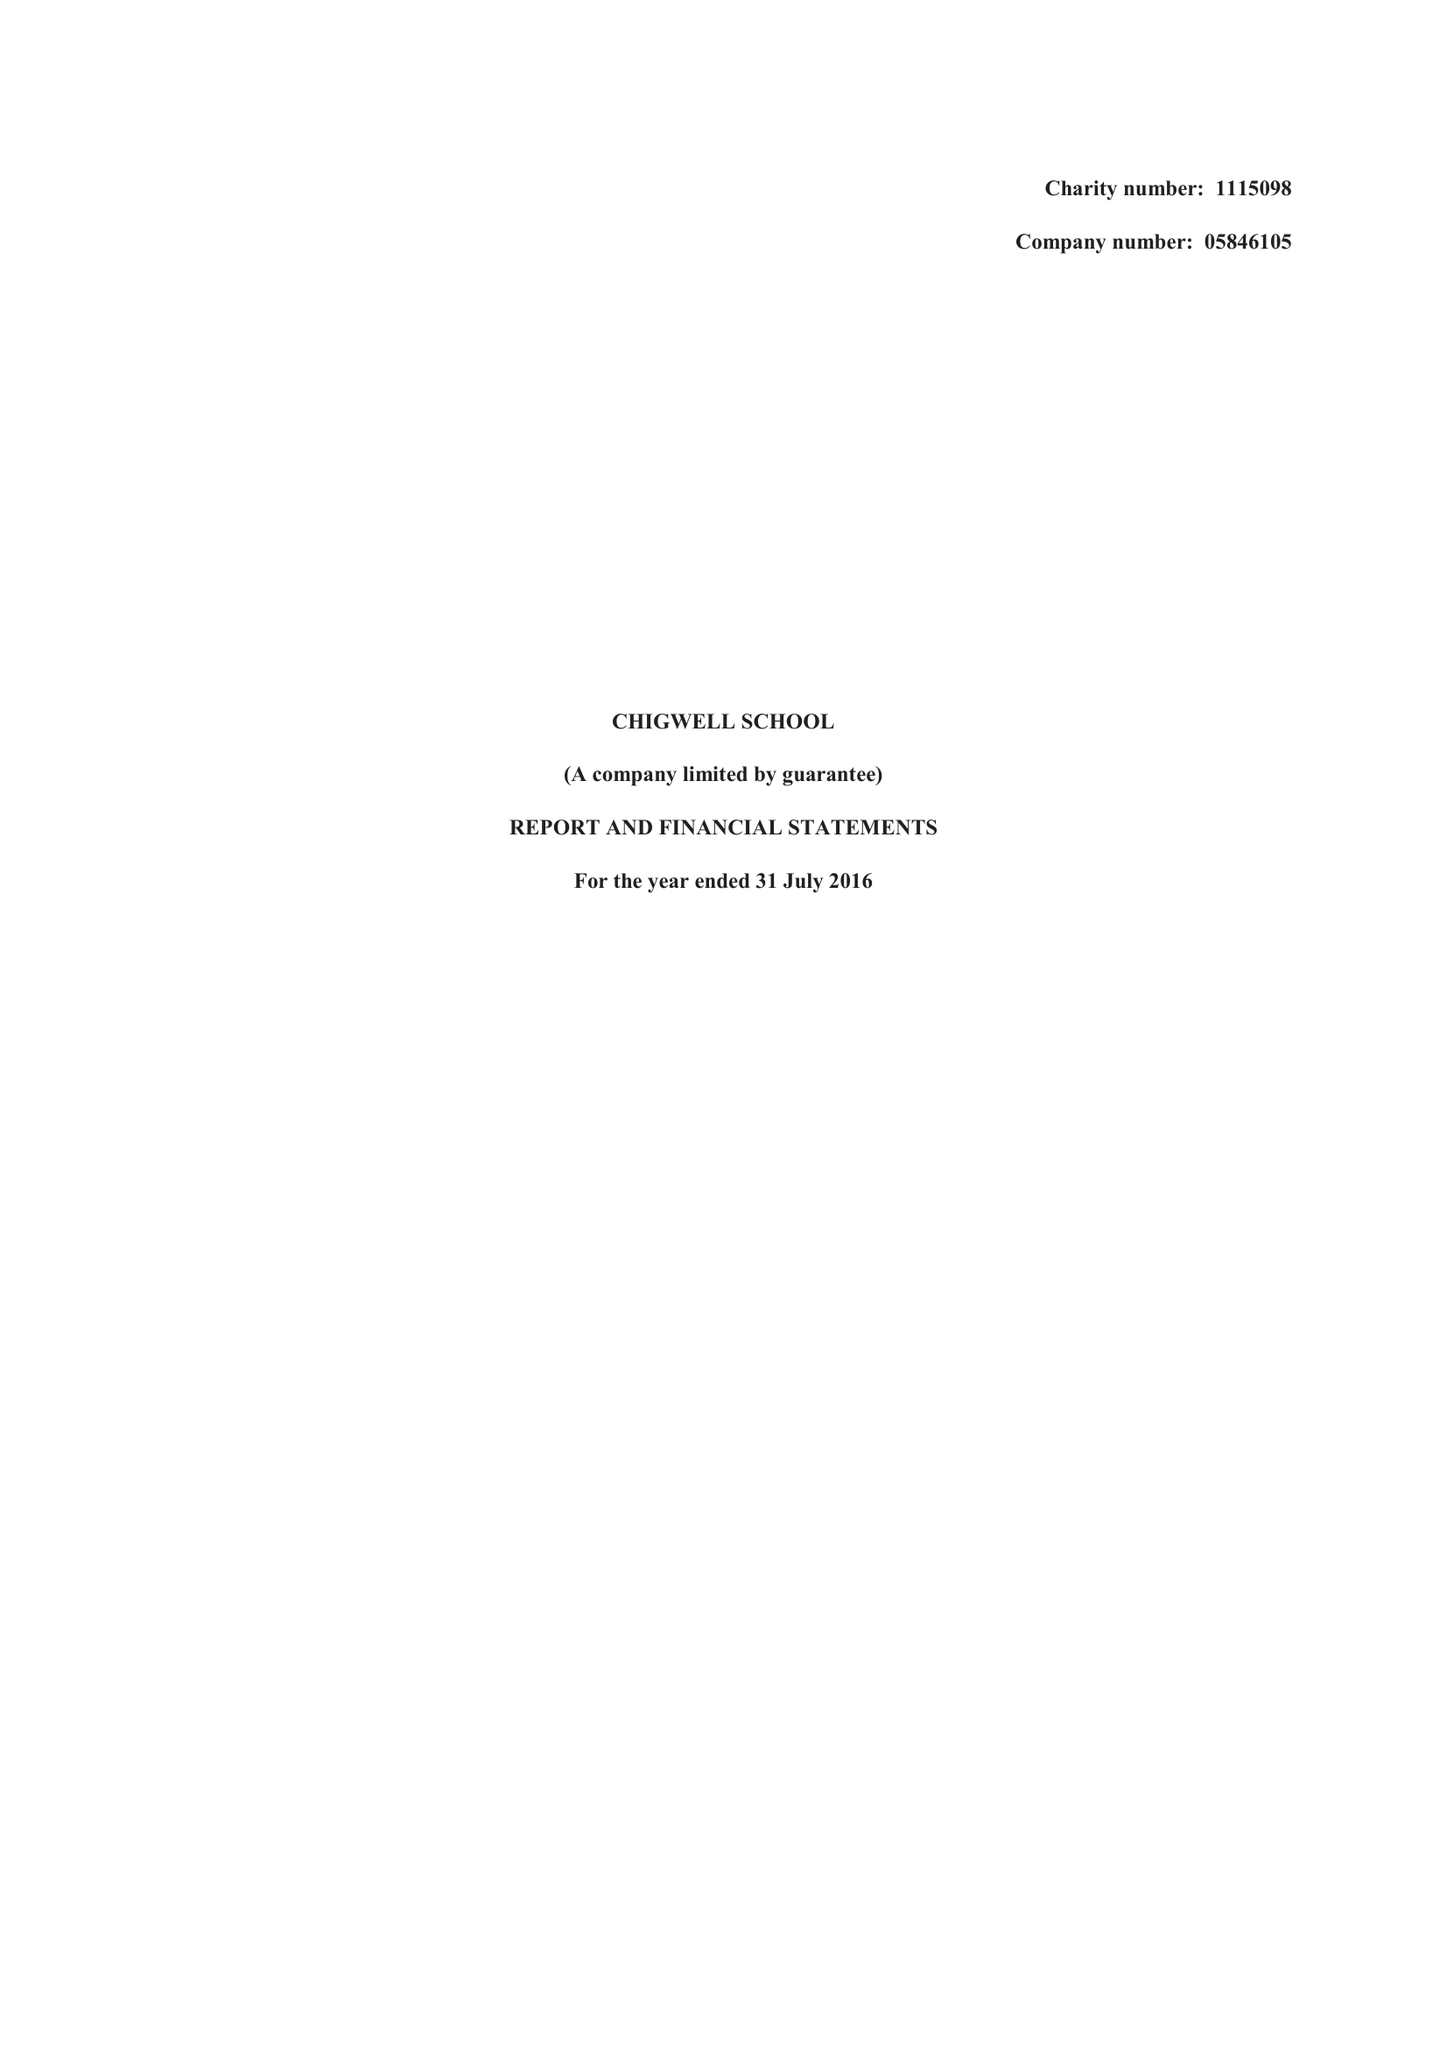What is the value for the spending_annually_in_british_pounds?
Answer the question using a single word or phrase. 11917000.00 